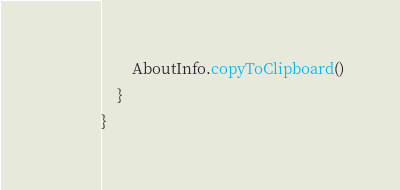<code> <loc_0><loc_0><loc_500><loc_500><_Kotlin_>        AboutInfo.copyToClipboard()
    }
}
</code> 